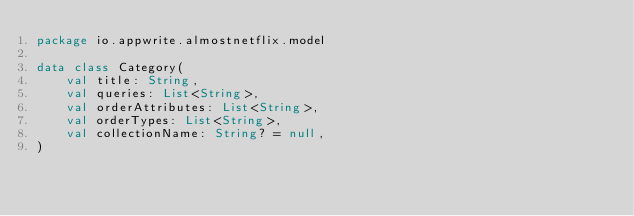<code> <loc_0><loc_0><loc_500><loc_500><_Kotlin_>package io.appwrite.almostnetflix.model

data class Category(
    val title: String,
    val queries: List<String>,
    val orderAttributes: List<String>,
    val orderTypes: List<String>,
    val collectionName: String? = null,
)</code> 